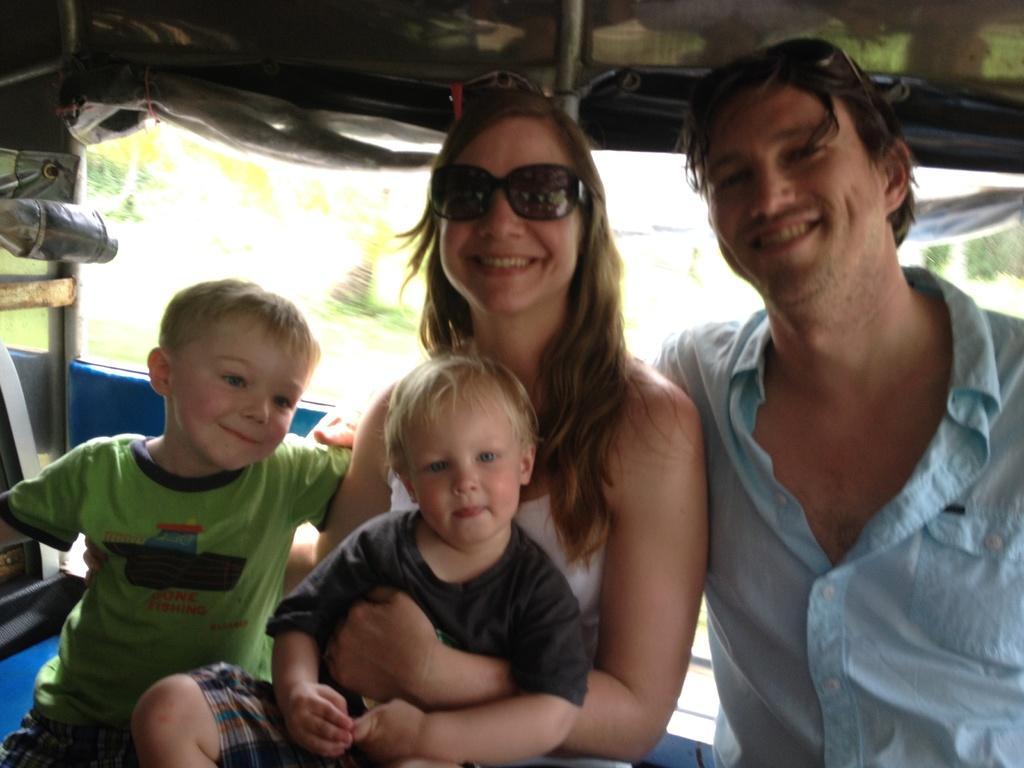Describe this image in one or two sentences. In the center of the image there are two persons and two kids. In the background of the image there are trees. At the top of the image there is a cover. 